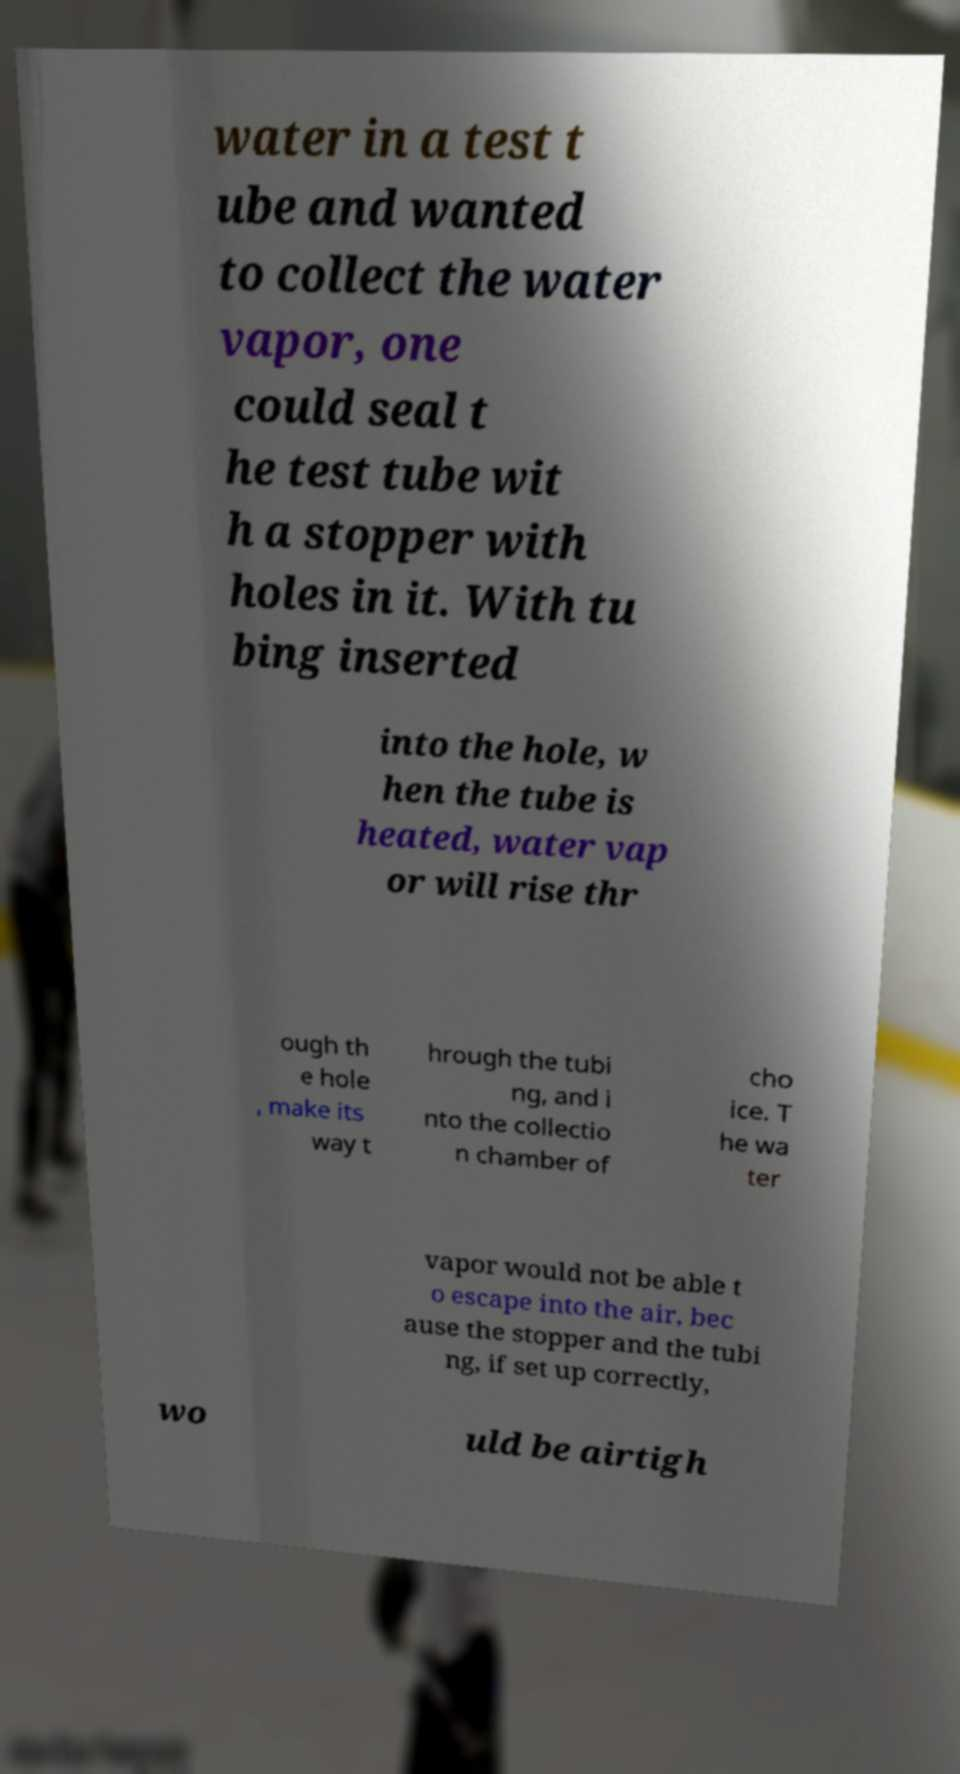Please identify and transcribe the text found in this image. water in a test t ube and wanted to collect the water vapor, one could seal t he test tube wit h a stopper with holes in it. With tu bing inserted into the hole, w hen the tube is heated, water vap or will rise thr ough th e hole , make its way t hrough the tubi ng, and i nto the collectio n chamber of cho ice. T he wa ter vapor would not be able t o escape into the air, bec ause the stopper and the tubi ng, if set up correctly, wo uld be airtigh 